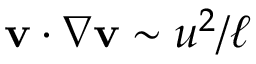Convert formula to latex. <formula><loc_0><loc_0><loc_500><loc_500>v \cdot \nabla v \sim u ^ { 2 } / \ell</formula> 